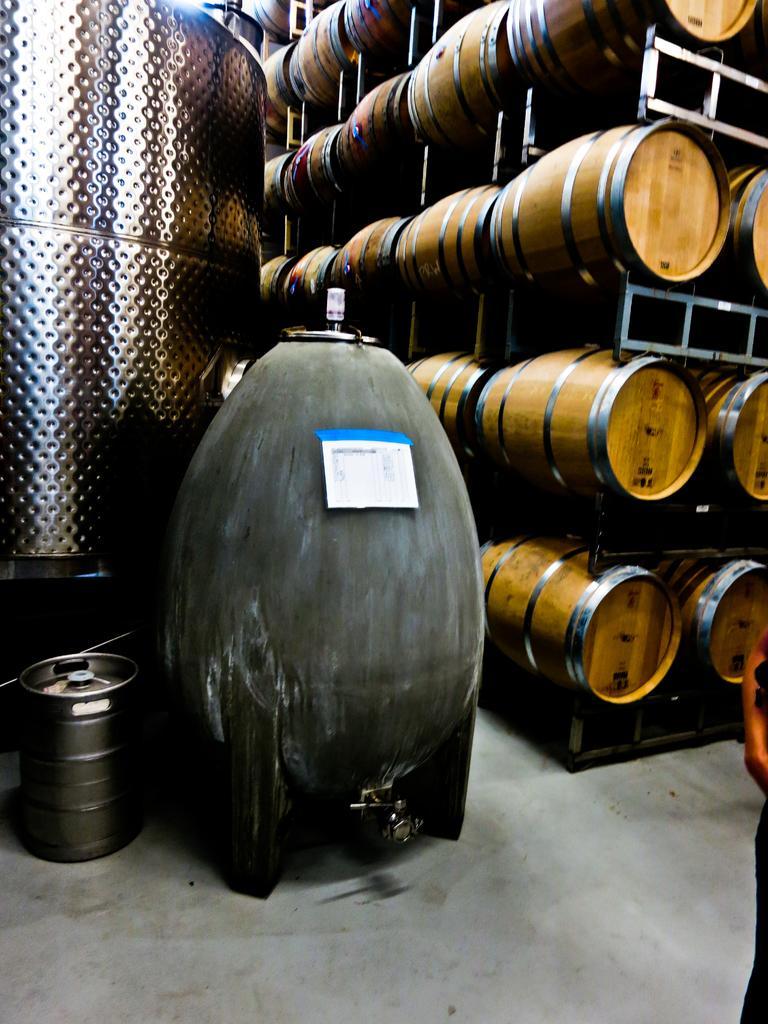In one or two sentences, can you explain what this image depicts? In this image there are shelves, in that shelves there are drums and there is a drum on a floor. 